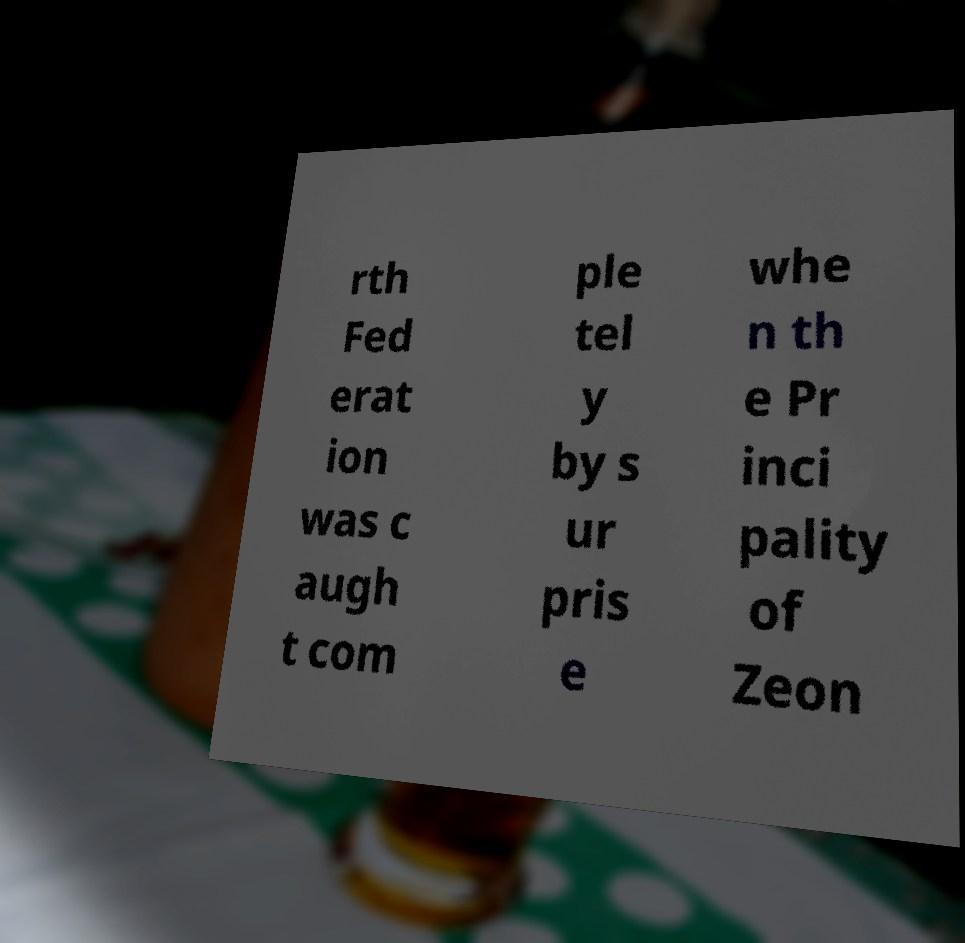Could you extract and type out the text from this image? rth Fed erat ion was c augh t com ple tel y by s ur pris e whe n th e Pr inci pality of Zeon 